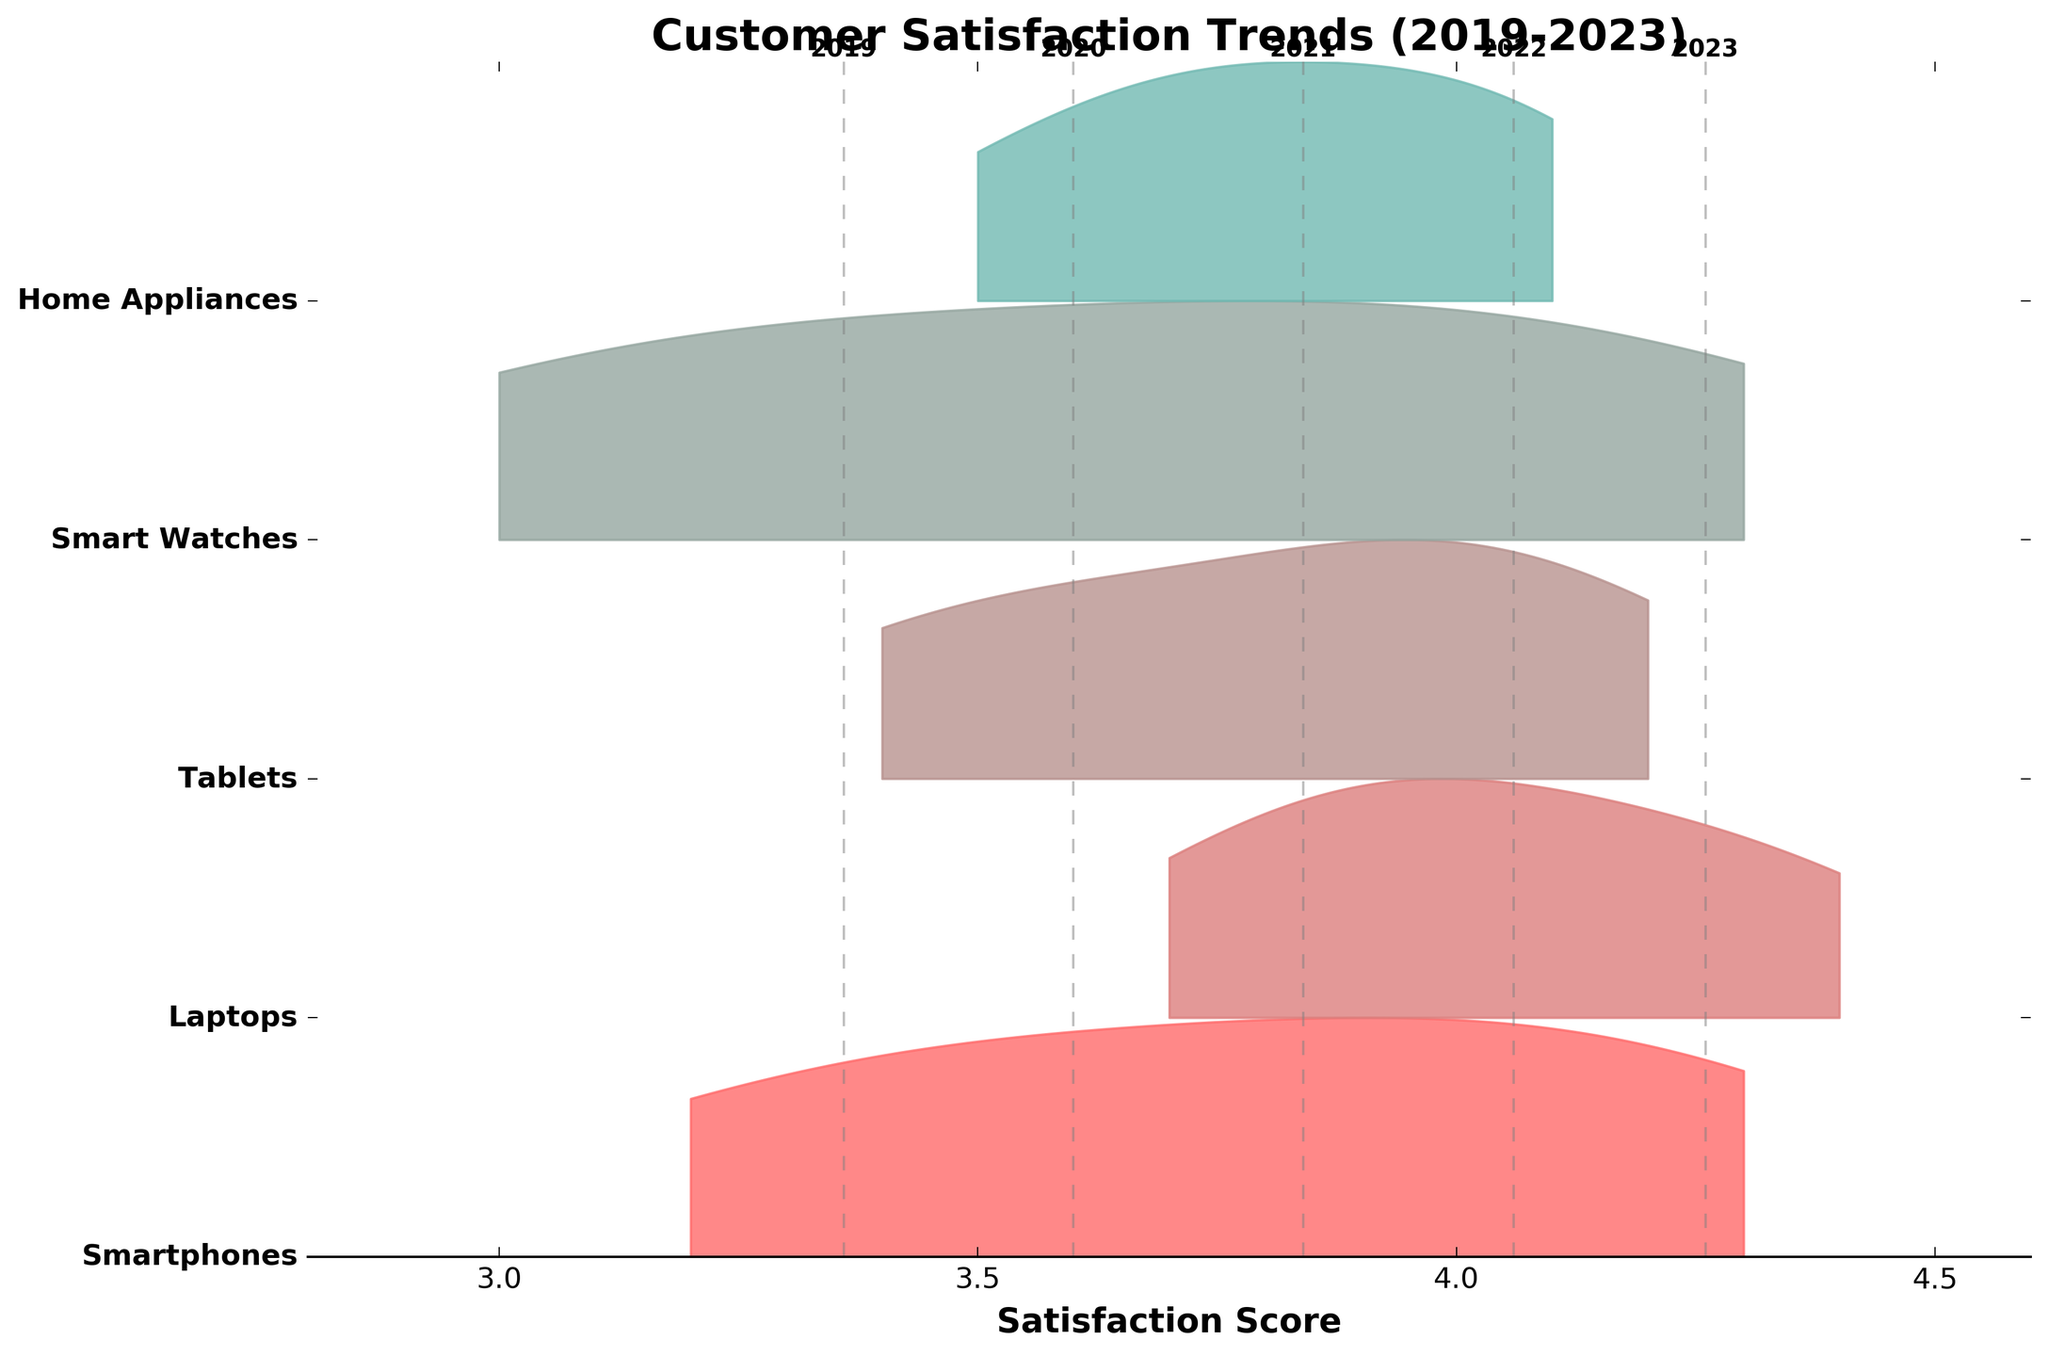What is the title of the plot? The title is positioned above the plot where it is common for titles to be located. By examining the figure, we see this text at the top.
Answer: Customer Satisfaction Trends (2019-2023) What product line had the highest satisfaction score in 2023? By looking at the plot, we can identify the satisfaction scores for each product line in 2023. The product line with the peak score at the highest point in the 2023 section of the plot is Laptops.
Answer: Laptops How have smartphones' satisfaction scores changed over the last 5 years? We can trace the density curve for Smartphones from 2019 to 2023. The curve steadily increases, showing greater satisfaction over time. Key points to note are: 3.2 in 2019, 3.5 in 2020, 3.8 in 2021, 4.1 in 2022, and 4.3 in 2023.
Answer: Increased Which product line showed the most significant improvement in customer satisfaction between 2019 and 2023? Tracking each product line from 2019 to 2023, we see that Smart Watches had a starting score of 3.0 in 2019 and rose to 4.3 in 2023, showing the most substantial improvement of +1.3. This is more considerable than the improvements for other product lines.
Answer: Smart Watches What are the range limits of the x-axis in the plot? The x-axis range is indicated by the horizontal limits. From visual inspection, the plot starts at 2.8 and ends at 4.6, which are the minimum and maximum values shown.
Answer: 2.8 to 4.6 Are there any noticeable trends for Home Appliances over the years? Observing the Home Appliances curve through the years from left to right, the satisfaction score progresses slightly but steadily upward from 3.5 in 2019 to 4.1 in 2023, showing a consistent rising trend.
Answer: Consistent increase Is there a product line that maintained consistent satisfaction score growth each year? We examine each product line’s trend from 2019 to 2023. Laptops, Tablets, and Smart Watches all show a steady, year-by-year increase in satisfaction scores, indicating consistent growth.
Answer: Yes, Laptops, Tablets, Smart Watches Which year had the lowest average satisfaction score across all product lines? Grey dashed lines represent the average satisfaction score per year. Observing the placements of the lines and their corresponding annotations, the line for 2019 is the leftmost around the 3.3 mark, indicating the lowest average score.
Answer: 2019 What can we deduce about the overall trend in customer satisfaction from 2019 to 2023? By examining the plot as a whole, it’s evident that most product lines have an upward trend from 2019 to 2023. This indicates that customer satisfaction scores have generally been improving over this period.
Answer: Increasing 